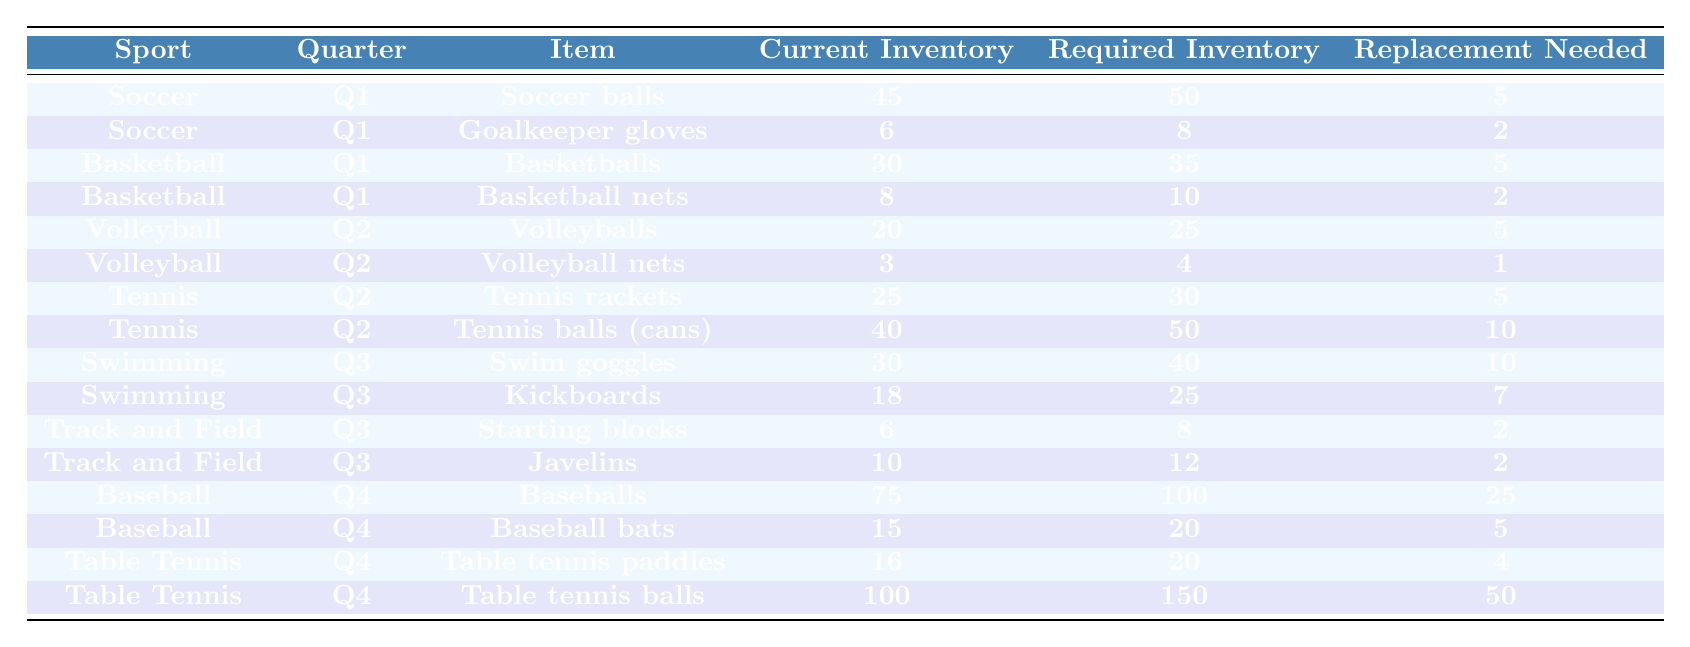What is the current inventory of soccer balls? The table shows the current inventory for each item in the specified sport. For soccer balls, the current inventory is listed as 45.
Answer: 45 How many more basketballs are needed to meet the required inventory? The required inventory for basketballs is 35, and the current inventory is 30. To find how many more are needed, subtract the current inventory from the required inventory: 35 - 30 = 5.
Answer: 5 Are there more replacements needed for table tennis balls or table tennis paddles? The table indicates that table tennis balls require 50 replacements while table tennis paddles need 4. Since 50 is greater than 4, more replacements are needed for table tennis balls.
Answer: Yes, more replacements are needed for table tennis balls What is the total replacement needed for volleyballs and volleyball nets combined? The table shows that volleyballs need 5 replacements and volleyball nets need 1. Adding these together gives: 5 + 1 = 6.
Answer: 6 Which sport has the highest replacement need overall? We look at each sport's replacement needs in the table. Baseball has 25 replacements needed for baseballs and 5 for bats, totaling 30. Table tennis has 50 for balls and 4 for paddles, totaling 54. Table tennis has the highest replacement need overall.
Answer: Table tennis How many more kickboards are needed to meet the required inventory? The required inventory for kickboards is 25, and the current inventory is 18. To find out how many more are needed, subtract: 25 - 18 = 7.
Answer: 7 What is the total required inventory for tennis equipment? The table lists 30 for tennis rackets and 50 for tennis balls. Adding these together gives: 30 + 50 = 80.
Answer: 80 Is the current inventory for javelins sufficient to meet the required inventory? The required inventory for javelins is 12 and the current inventory is 10. Since 10 is less than 12, the current inventory is insufficient.
Answer: No, it is not sufficient What percentage of the current inventory of swim goggles is needed to meet the required inventory? The current inventory of swim goggles is 30 and the required inventory is 40. To find the percentage needed: (40 - 30) / 40 * 100 = 25%.
Answer: 25% What is the difference in current inventory between baseballs and baseball bats? The current inventory for baseballs is 75 and for baseball bats is 15. The difference is 75 - 15 = 60.
Answer: 60 Which sport has the second-highest required inventory after baseball? After examining the table, soccer has a required inventory of 50 for soccer balls, while the required for baseballs is 100. The next highest after baseball is soccer.
Answer: Soccer 